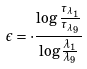Convert formula to latex. <formula><loc_0><loc_0><loc_500><loc_500>\epsilon = \cdot \frac { \log \frac { \tau _ { \lambda _ { 1 } } } { \tau _ { \lambda _ { 9 } } } } { \log \frac { \lambda _ { 1 } } { \lambda _ { 9 } } }</formula> 